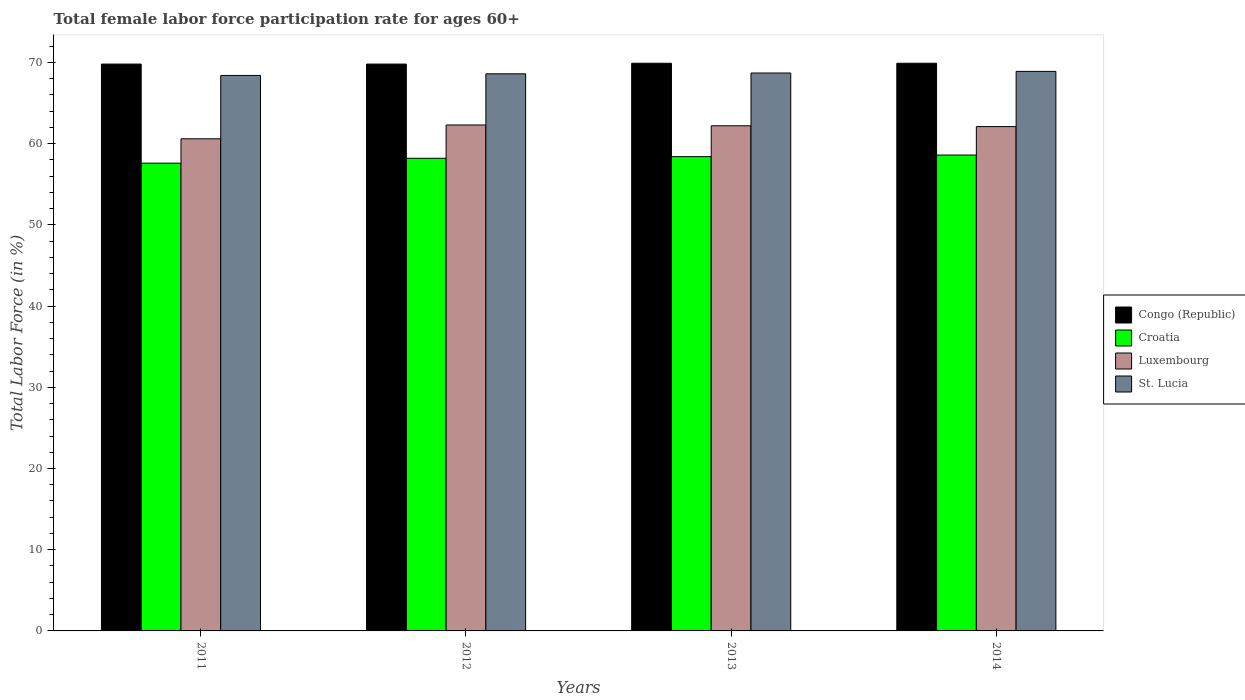Are the number of bars per tick equal to the number of legend labels?
Give a very brief answer. Yes. Are the number of bars on each tick of the X-axis equal?
Your answer should be very brief. Yes. How many bars are there on the 2nd tick from the left?
Give a very brief answer. 4. What is the label of the 3rd group of bars from the left?
Give a very brief answer. 2013. What is the female labor force participation rate in Congo (Republic) in 2013?
Your response must be concise. 69.9. Across all years, what is the maximum female labor force participation rate in Luxembourg?
Provide a succinct answer. 62.3. Across all years, what is the minimum female labor force participation rate in Croatia?
Provide a succinct answer. 57.6. In which year was the female labor force participation rate in Congo (Republic) minimum?
Your answer should be very brief. 2011. What is the total female labor force participation rate in St. Lucia in the graph?
Your answer should be compact. 274.6. What is the difference between the female labor force participation rate in Congo (Republic) in 2012 and that in 2014?
Offer a very short reply. -0.1. What is the difference between the female labor force participation rate in St. Lucia in 2014 and the female labor force participation rate in Croatia in 2013?
Provide a succinct answer. 10.5. What is the average female labor force participation rate in Croatia per year?
Offer a terse response. 58.2. In the year 2012, what is the difference between the female labor force participation rate in St. Lucia and female labor force participation rate in Luxembourg?
Provide a short and direct response. 6.3. In how many years, is the female labor force participation rate in Luxembourg greater than 56 %?
Provide a succinct answer. 4. What is the ratio of the female labor force participation rate in Luxembourg in 2013 to that in 2014?
Provide a short and direct response. 1. Is the female labor force participation rate in Croatia in 2011 less than that in 2012?
Give a very brief answer. Yes. What is the difference between the highest and the second highest female labor force participation rate in Croatia?
Offer a very short reply. 0.2. What is the difference between the highest and the lowest female labor force participation rate in Croatia?
Offer a very short reply. 1. In how many years, is the female labor force participation rate in Croatia greater than the average female labor force participation rate in Croatia taken over all years?
Make the answer very short. 3. Is it the case that in every year, the sum of the female labor force participation rate in Congo (Republic) and female labor force participation rate in Croatia is greater than the sum of female labor force participation rate in St. Lucia and female labor force participation rate in Luxembourg?
Your answer should be very brief. Yes. What does the 2nd bar from the left in 2013 represents?
Your answer should be very brief. Croatia. What does the 2nd bar from the right in 2012 represents?
Provide a succinct answer. Luxembourg. Is it the case that in every year, the sum of the female labor force participation rate in Luxembourg and female labor force participation rate in Congo (Republic) is greater than the female labor force participation rate in St. Lucia?
Your response must be concise. Yes. How many bars are there?
Provide a short and direct response. 16. Are all the bars in the graph horizontal?
Your response must be concise. No. How many years are there in the graph?
Provide a succinct answer. 4. What is the difference between two consecutive major ticks on the Y-axis?
Offer a terse response. 10. Are the values on the major ticks of Y-axis written in scientific E-notation?
Your answer should be compact. No. Does the graph contain any zero values?
Your answer should be compact. No. Does the graph contain grids?
Your answer should be compact. No. Where does the legend appear in the graph?
Provide a short and direct response. Center right. How are the legend labels stacked?
Make the answer very short. Vertical. What is the title of the graph?
Offer a terse response. Total female labor force participation rate for ages 60+. Does "Moldova" appear as one of the legend labels in the graph?
Your answer should be very brief. No. What is the label or title of the X-axis?
Offer a terse response. Years. What is the label or title of the Y-axis?
Ensure brevity in your answer.  Total Labor Force (in %). What is the Total Labor Force (in %) of Congo (Republic) in 2011?
Ensure brevity in your answer.  69.8. What is the Total Labor Force (in %) of Croatia in 2011?
Give a very brief answer. 57.6. What is the Total Labor Force (in %) of Luxembourg in 2011?
Give a very brief answer. 60.6. What is the Total Labor Force (in %) of St. Lucia in 2011?
Offer a terse response. 68.4. What is the Total Labor Force (in %) of Congo (Republic) in 2012?
Give a very brief answer. 69.8. What is the Total Labor Force (in %) in Croatia in 2012?
Your answer should be compact. 58.2. What is the Total Labor Force (in %) of Luxembourg in 2012?
Your answer should be compact. 62.3. What is the Total Labor Force (in %) in St. Lucia in 2012?
Your answer should be compact. 68.6. What is the Total Labor Force (in %) in Congo (Republic) in 2013?
Your response must be concise. 69.9. What is the Total Labor Force (in %) of Croatia in 2013?
Offer a very short reply. 58.4. What is the Total Labor Force (in %) of Luxembourg in 2013?
Make the answer very short. 62.2. What is the Total Labor Force (in %) of St. Lucia in 2013?
Offer a very short reply. 68.7. What is the Total Labor Force (in %) in Congo (Republic) in 2014?
Ensure brevity in your answer.  69.9. What is the Total Labor Force (in %) in Croatia in 2014?
Ensure brevity in your answer.  58.6. What is the Total Labor Force (in %) of Luxembourg in 2014?
Give a very brief answer. 62.1. What is the Total Labor Force (in %) of St. Lucia in 2014?
Your response must be concise. 68.9. Across all years, what is the maximum Total Labor Force (in %) of Congo (Republic)?
Give a very brief answer. 69.9. Across all years, what is the maximum Total Labor Force (in %) of Croatia?
Your answer should be compact. 58.6. Across all years, what is the maximum Total Labor Force (in %) in Luxembourg?
Provide a short and direct response. 62.3. Across all years, what is the maximum Total Labor Force (in %) in St. Lucia?
Provide a short and direct response. 68.9. Across all years, what is the minimum Total Labor Force (in %) in Congo (Republic)?
Offer a very short reply. 69.8. Across all years, what is the minimum Total Labor Force (in %) in Croatia?
Provide a succinct answer. 57.6. Across all years, what is the minimum Total Labor Force (in %) in Luxembourg?
Provide a short and direct response. 60.6. Across all years, what is the minimum Total Labor Force (in %) in St. Lucia?
Offer a very short reply. 68.4. What is the total Total Labor Force (in %) of Congo (Republic) in the graph?
Keep it short and to the point. 279.4. What is the total Total Labor Force (in %) of Croatia in the graph?
Offer a terse response. 232.8. What is the total Total Labor Force (in %) of Luxembourg in the graph?
Your response must be concise. 247.2. What is the total Total Labor Force (in %) of St. Lucia in the graph?
Your answer should be compact. 274.6. What is the difference between the Total Labor Force (in %) of Luxembourg in 2011 and that in 2012?
Offer a very short reply. -1.7. What is the difference between the Total Labor Force (in %) in St. Lucia in 2011 and that in 2012?
Provide a succinct answer. -0.2. What is the difference between the Total Labor Force (in %) of Congo (Republic) in 2011 and that in 2013?
Keep it short and to the point. -0.1. What is the difference between the Total Labor Force (in %) in Croatia in 2011 and that in 2013?
Keep it short and to the point. -0.8. What is the difference between the Total Labor Force (in %) in Luxembourg in 2011 and that in 2013?
Your response must be concise. -1.6. What is the difference between the Total Labor Force (in %) of Croatia in 2011 and that in 2014?
Your answer should be compact. -1. What is the difference between the Total Labor Force (in %) in Luxembourg in 2011 and that in 2014?
Offer a terse response. -1.5. What is the difference between the Total Labor Force (in %) of Croatia in 2012 and that in 2013?
Your response must be concise. -0.2. What is the difference between the Total Labor Force (in %) in Luxembourg in 2012 and that in 2013?
Provide a short and direct response. 0.1. What is the difference between the Total Labor Force (in %) of Congo (Republic) in 2012 and that in 2014?
Offer a very short reply. -0.1. What is the difference between the Total Labor Force (in %) of Luxembourg in 2012 and that in 2014?
Make the answer very short. 0.2. What is the difference between the Total Labor Force (in %) of Luxembourg in 2013 and that in 2014?
Ensure brevity in your answer.  0.1. What is the difference between the Total Labor Force (in %) in Congo (Republic) in 2011 and the Total Labor Force (in %) in Croatia in 2012?
Your answer should be very brief. 11.6. What is the difference between the Total Labor Force (in %) in Congo (Republic) in 2011 and the Total Labor Force (in %) in St. Lucia in 2012?
Provide a short and direct response. 1.2. What is the difference between the Total Labor Force (in %) of Croatia in 2011 and the Total Labor Force (in %) of St. Lucia in 2012?
Your response must be concise. -11. What is the difference between the Total Labor Force (in %) in Luxembourg in 2011 and the Total Labor Force (in %) in St. Lucia in 2012?
Your answer should be very brief. -8. What is the difference between the Total Labor Force (in %) of Congo (Republic) in 2011 and the Total Labor Force (in %) of Luxembourg in 2013?
Your response must be concise. 7.6. What is the difference between the Total Labor Force (in %) in Croatia in 2011 and the Total Labor Force (in %) in Luxembourg in 2013?
Your answer should be very brief. -4.6. What is the difference between the Total Labor Force (in %) of Luxembourg in 2011 and the Total Labor Force (in %) of St. Lucia in 2013?
Your answer should be very brief. -8.1. What is the difference between the Total Labor Force (in %) in Croatia in 2011 and the Total Labor Force (in %) in Luxembourg in 2014?
Your answer should be compact. -4.5. What is the difference between the Total Labor Force (in %) of Congo (Republic) in 2012 and the Total Labor Force (in %) of Croatia in 2013?
Keep it short and to the point. 11.4. What is the difference between the Total Labor Force (in %) of Congo (Republic) in 2012 and the Total Labor Force (in %) of St. Lucia in 2013?
Make the answer very short. 1.1. What is the difference between the Total Labor Force (in %) in Croatia in 2012 and the Total Labor Force (in %) in Luxembourg in 2013?
Keep it short and to the point. -4. What is the difference between the Total Labor Force (in %) in Congo (Republic) in 2012 and the Total Labor Force (in %) in Croatia in 2014?
Ensure brevity in your answer.  11.2. What is the difference between the Total Labor Force (in %) in Croatia in 2012 and the Total Labor Force (in %) in St. Lucia in 2014?
Your response must be concise. -10.7. What is the difference between the Total Labor Force (in %) of Luxembourg in 2012 and the Total Labor Force (in %) of St. Lucia in 2014?
Give a very brief answer. -6.6. What is the difference between the Total Labor Force (in %) of Congo (Republic) in 2013 and the Total Labor Force (in %) of St. Lucia in 2014?
Provide a succinct answer. 1. What is the difference between the Total Labor Force (in %) in Croatia in 2013 and the Total Labor Force (in %) in Luxembourg in 2014?
Your answer should be very brief. -3.7. What is the difference between the Total Labor Force (in %) of Luxembourg in 2013 and the Total Labor Force (in %) of St. Lucia in 2014?
Provide a short and direct response. -6.7. What is the average Total Labor Force (in %) in Congo (Republic) per year?
Keep it short and to the point. 69.85. What is the average Total Labor Force (in %) in Croatia per year?
Provide a succinct answer. 58.2. What is the average Total Labor Force (in %) of Luxembourg per year?
Offer a very short reply. 61.8. What is the average Total Labor Force (in %) in St. Lucia per year?
Ensure brevity in your answer.  68.65. In the year 2011, what is the difference between the Total Labor Force (in %) in Congo (Republic) and Total Labor Force (in %) in Luxembourg?
Provide a short and direct response. 9.2. In the year 2011, what is the difference between the Total Labor Force (in %) of Luxembourg and Total Labor Force (in %) of St. Lucia?
Offer a terse response. -7.8. In the year 2012, what is the difference between the Total Labor Force (in %) of Congo (Republic) and Total Labor Force (in %) of Croatia?
Ensure brevity in your answer.  11.6. In the year 2012, what is the difference between the Total Labor Force (in %) in Congo (Republic) and Total Labor Force (in %) in Luxembourg?
Offer a terse response. 7.5. In the year 2012, what is the difference between the Total Labor Force (in %) of Congo (Republic) and Total Labor Force (in %) of St. Lucia?
Ensure brevity in your answer.  1.2. In the year 2012, what is the difference between the Total Labor Force (in %) of Luxembourg and Total Labor Force (in %) of St. Lucia?
Give a very brief answer. -6.3. In the year 2013, what is the difference between the Total Labor Force (in %) in Congo (Republic) and Total Labor Force (in %) in Croatia?
Your answer should be compact. 11.5. In the year 2013, what is the difference between the Total Labor Force (in %) in Congo (Republic) and Total Labor Force (in %) in Luxembourg?
Provide a short and direct response. 7.7. In the year 2013, what is the difference between the Total Labor Force (in %) in Congo (Republic) and Total Labor Force (in %) in St. Lucia?
Your response must be concise. 1.2. In the year 2013, what is the difference between the Total Labor Force (in %) in Croatia and Total Labor Force (in %) in St. Lucia?
Provide a succinct answer. -10.3. In the year 2014, what is the difference between the Total Labor Force (in %) in Congo (Republic) and Total Labor Force (in %) in Croatia?
Keep it short and to the point. 11.3. In the year 2014, what is the difference between the Total Labor Force (in %) in Congo (Republic) and Total Labor Force (in %) in Luxembourg?
Your response must be concise. 7.8. In the year 2014, what is the difference between the Total Labor Force (in %) of Croatia and Total Labor Force (in %) of Luxembourg?
Provide a short and direct response. -3.5. In the year 2014, what is the difference between the Total Labor Force (in %) in Croatia and Total Labor Force (in %) in St. Lucia?
Your response must be concise. -10.3. What is the ratio of the Total Labor Force (in %) of Croatia in 2011 to that in 2012?
Offer a terse response. 0.99. What is the ratio of the Total Labor Force (in %) in Luxembourg in 2011 to that in 2012?
Give a very brief answer. 0.97. What is the ratio of the Total Labor Force (in %) in Croatia in 2011 to that in 2013?
Provide a short and direct response. 0.99. What is the ratio of the Total Labor Force (in %) in Luxembourg in 2011 to that in 2013?
Your answer should be very brief. 0.97. What is the ratio of the Total Labor Force (in %) in Croatia in 2011 to that in 2014?
Ensure brevity in your answer.  0.98. What is the ratio of the Total Labor Force (in %) in Luxembourg in 2011 to that in 2014?
Your answer should be very brief. 0.98. What is the ratio of the Total Labor Force (in %) in St. Lucia in 2011 to that in 2014?
Give a very brief answer. 0.99. What is the ratio of the Total Labor Force (in %) of Congo (Republic) in 2012 to that in 2013?
Offer a very short reply. 1. What is the ratio of the Total Labor Force (in %) of Luxembourg in 2012 to that in 2013?
Your answer should be compact. 1. What is the ratio of the Total Labor Force (in %) of St. Lucia in 2012 to that in 2013?
Keep it short and to the point. 1. What is the ratio of the Total Labor Force (in %) in Luxembourg in 2012 to that in 2014?
Make the answer very short. 1. What is the ratio of the Total Labor Force (in %) of St. Lucia in 2012 to that in 2014?
Your answer should be compact. 1. What is the ratio of the Total Labor Force (in %) in Croatia in 2013 to that in 2014?
Your response must be concise. 1. What is the ratio of the Total Labor Force (in %) of Luxembourg in 2013 to that in 2014?
Offer a very short reply. 1. What is the difference between the highest and the second highest Total Labor Force (in %) in Congo (Republic)?
Provide a succinct answer. 0. What is the difference between the highest and the second highest Total Labor Force (in %) in Croatia?
Offer a terse response. 0.2. What is the difference between the highest and the lowest Total Labor Force (in %) in Luxembourg?
Provide a short and direct response. 1.7. What is the difference between the highest and the lowest Total Labor Force (in %) of St. Lucia?
Ensure brevity in your answer.  0.5. 